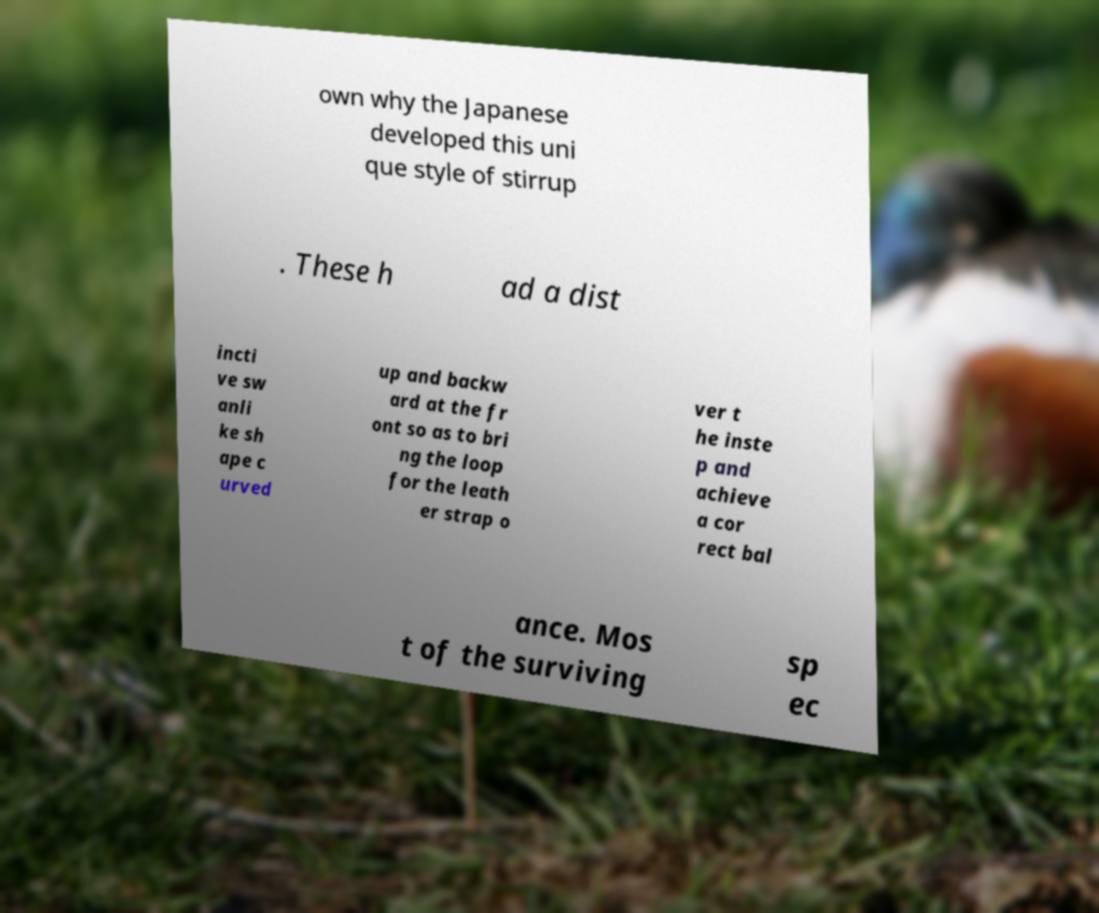What messages or text are displayed in this image? I need them in a readable, typed format. own why the Japanese developed this uni que style of stirrup . These h ad a dist incti ve sw anli ke sh ape c urved up and backw ard at the fr ont so as to bri ng the loop for the leath er strap o ver t he inste p and achieve a cor rect bal ance. Mos t of the surviving sp ec 